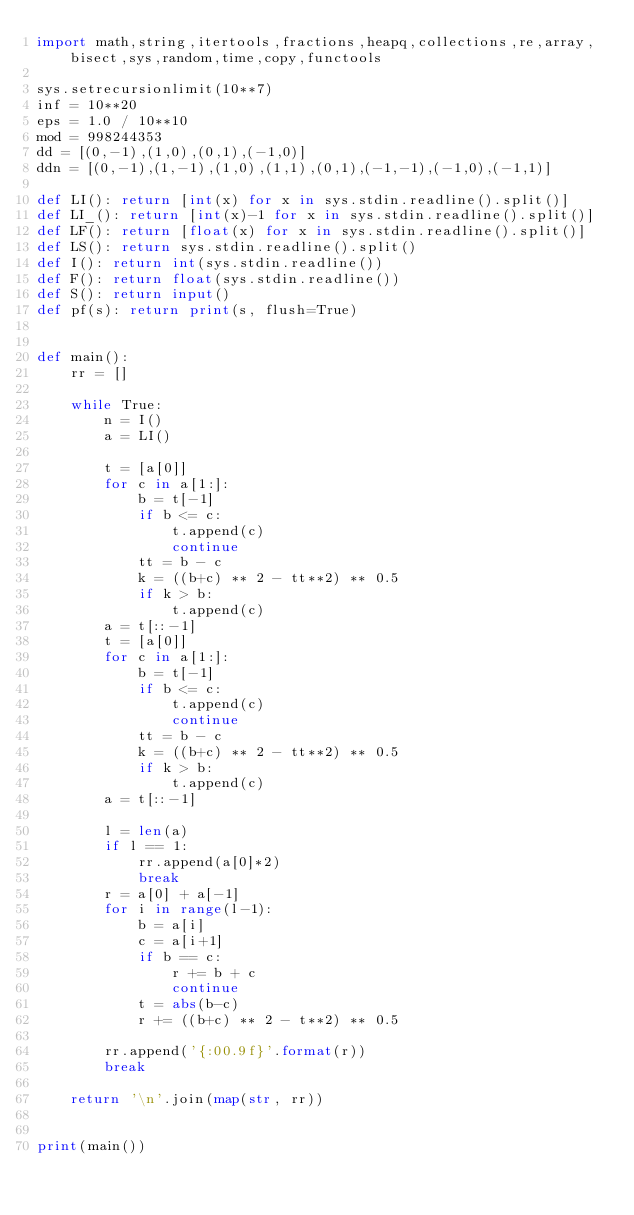<code> <loc_0><loc_0><loc_500><loc_500><_Python_>import math,string,itertools,fractions,heapq,collections,re,array,bisect,sys,random,time,copy,functools

sys.setrecursionlimit(10**7)
inf = 10**20
eps = 1.0 / 10**10
mod = 998244353
dd = [(0,-1),(1,0),(0,1),(-1,0)]
ddn = [(0,-1),(1,-1),(1,0),(1,1),(0,1),(-1,-1),(-1,0),(-1,1)]

def LI(): return [int(x) for x in sys.stdin.readline().split()]
def LI_(): return [int(x)-1 for x in sys.stdin.readline().split()]
def LF(): return [float(x) for x in sys.stdin.readline().split()]
def LS(): return sys.stdin.readline().split()
def I(): return int(sys.stdin.readline())
def F(): return float(sys.stdin.readline())
def S(): return input()
def pf(s): return print(s, flush=True)


def main():
    rr = []

    while True:
        n = I()
        a = LI()

        t = [a[0]]
        for c in a[1:]:
            b = t[-1]
            if b <= c:
                t.append(c)
                continue
            tt = b - c
            k = ((b+c) ** 2 - tt**2) ** 0.5
            if k > b:
                t.append(c)
        a = t[::-1]
        t = [a[0]]
        for c in a[1:]:
            b = t[-1]
            if b <= c:
                t.append(c)
                continue
            tt = b - c
            k = ((b+c) ** 2 - tt**2) ** 0.5
            if k > b:
                t.append(c)
        a = t[::-1]

        l = len(a)
        if l == 1:
            rr.append(a[0]*2)
            break
        r = a[0] + a[-1]
        for i in range(l-1):
            b = a[i]
            c = a[i+1]
            if b == c:
                r += b + c
                continue
            t = abs(b-c)
            r += ((b+c) ** 2 - t**2) ** 0.5

        rr.append('{:00.9f}'.format(r))
        break

    return '\n'.join(map(str, rr))


print(main())


</code> 